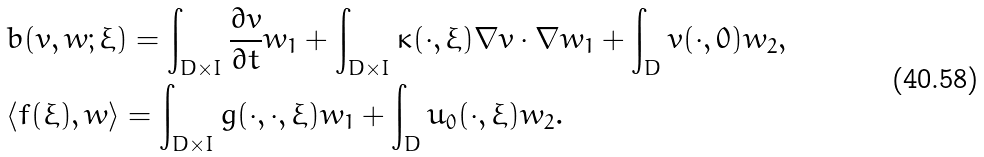<formula> <loc_0><loc_0><loc_500><loc_500>& b ( v , w ; \xi ) = \int _ { D \times I } \frac { \partial v } { \partial t } w _ { 1 } + \int _ { D \times I } \kappa ( \cdot , \xi ) \nabla v \cdot \nabla w _ { 1 } + \int _ { D } v ( \cdot , 0 ) w _ { 2 } , \\ & \langle f ( \xi ) , w \rangle = \int _ { D \times I } g ( \cdot , \cdot , \xi ) w _ { 1 } + \int _ { D } u _ { 0 } ( \cdot , \xi ) w _ { 2 } .</formula> 